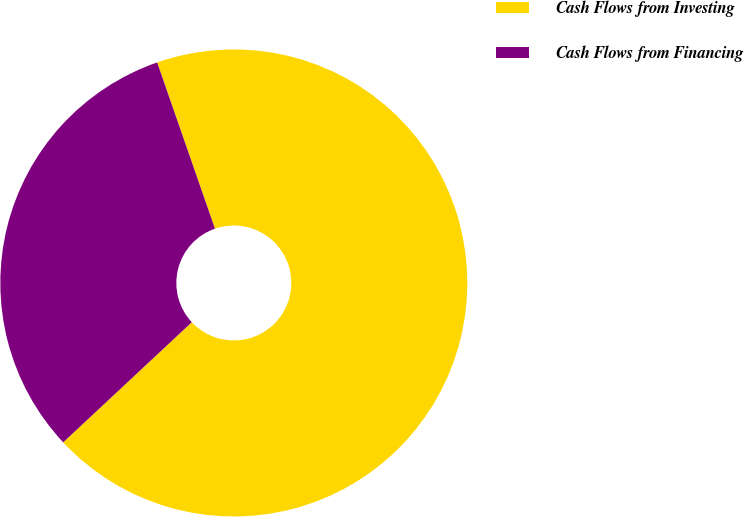<chart> <loc_0><loc_0><loc_500><loc_500><pie_chart><fcel>Cash Flows from Investing<fcel>Cash Flows from Financing<nl><fcel>68.37%<fcel>31.63%<nl></chart> 